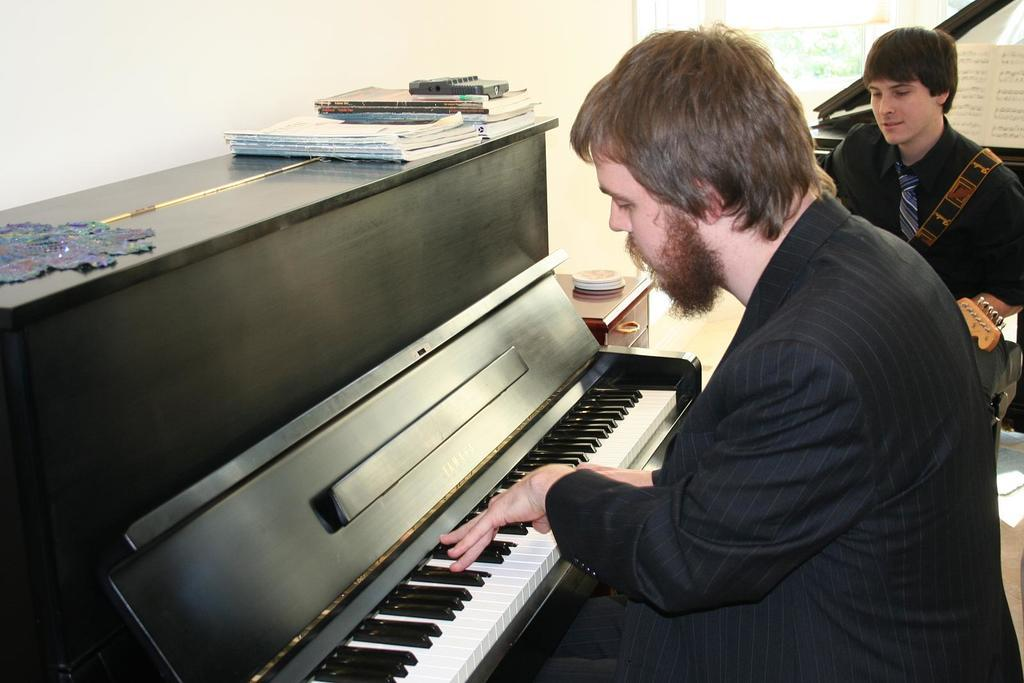How many people are sitting in the image? There are two people sitting in the image. What can be seen besides the people in the image? There is a musical instrument, books, and another person holding something in the image. What is the background of the image like? There is a wall and a cabinet in the image. What type of digestion can be observed in the image? There is no digestion present in the image; it is a scene involving people, a musical instrument, books, and a person holding something. Can you tell me how many bats are flying in the image? There are no bats present in the image. 